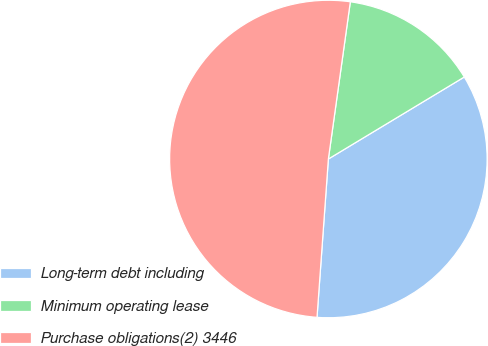<chart> <loc_0><loc_0><loc_500><loc_500><pie_chart><fcel>Long-term debt including<fcel>Minimum operating lease<fcel>Purchase obligations(2) 3446<nl><fcel>34.78%<fcel>14.15%<fcel>51.07%<nl></chart> 